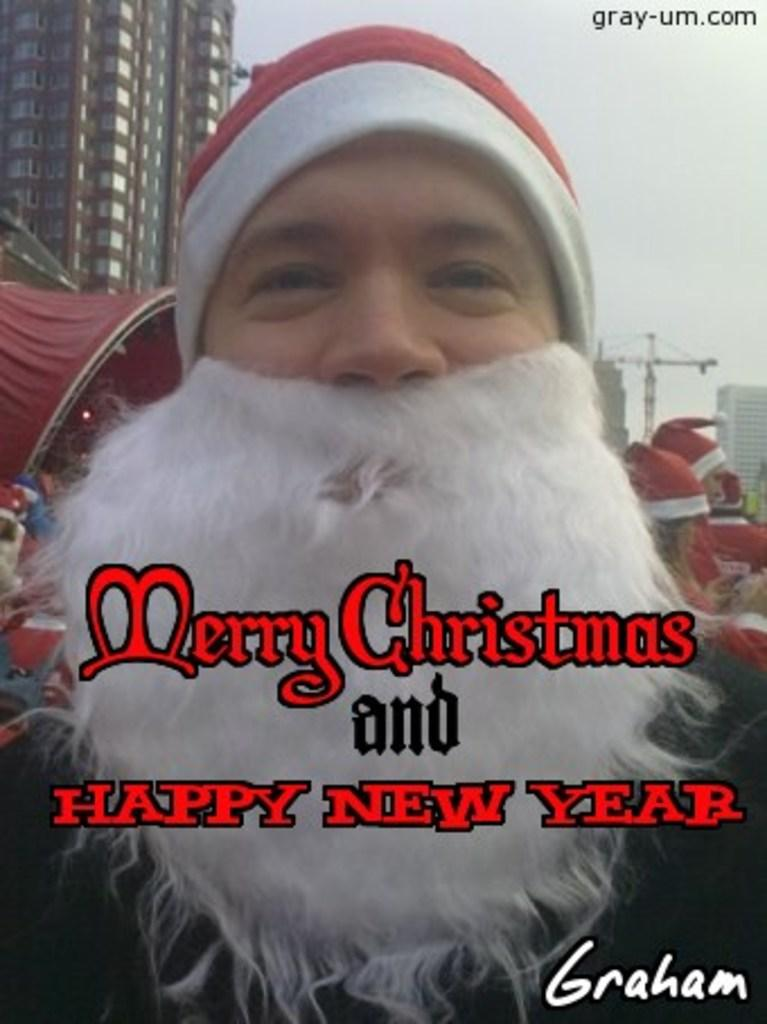What character is depicted in the image? There is a person dressed as Santa in the image. What can be seen in the background of the image? There are people wearing caps, buildings, windows, a crane, poles, and light visible in the background of the image. What other objects are present in the background of the image? Other objects are present in the background of the image. What type of circle is being drawn by the dog in the image? There is no dog present in the image, and therefore no such activity can be observed. What is the title of the image? The provided facts do not mention a title for the image. 